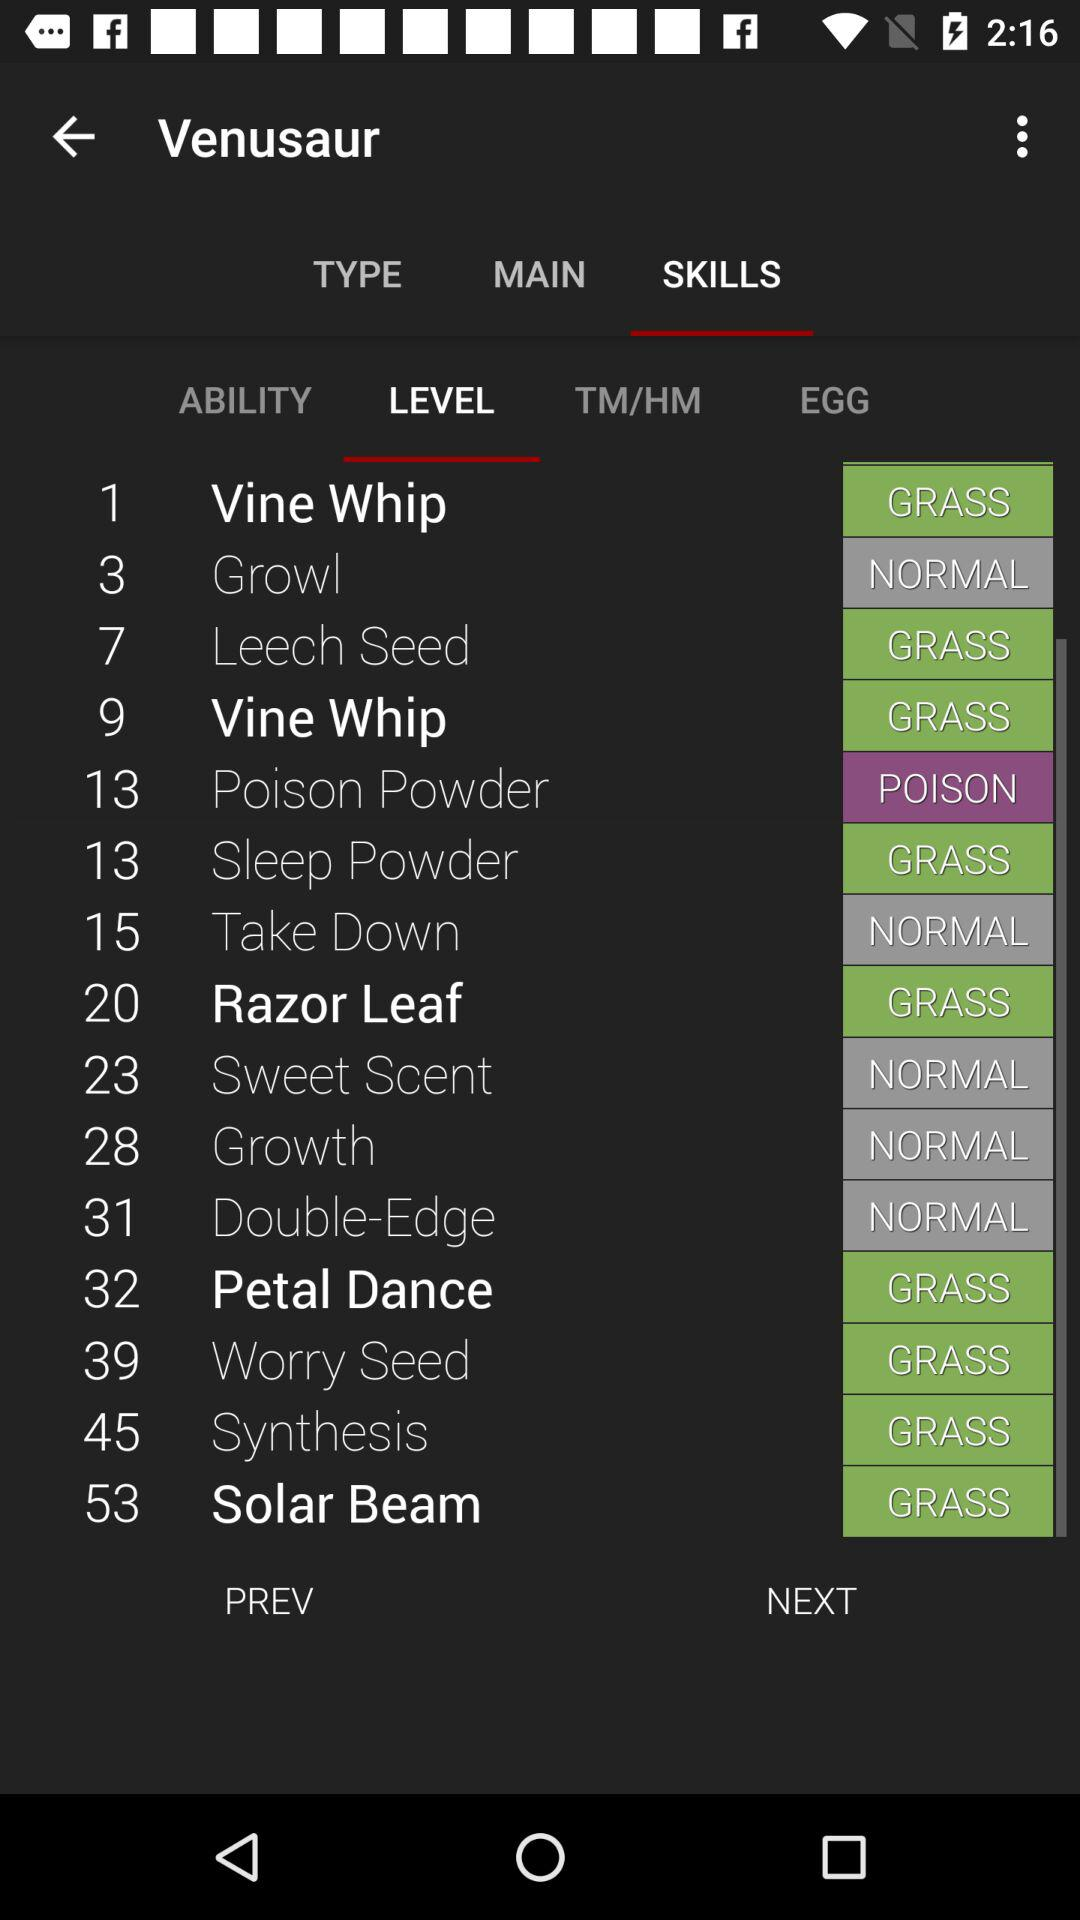What is the type of Vine Whip? Vine Whip is a Grass-type. 